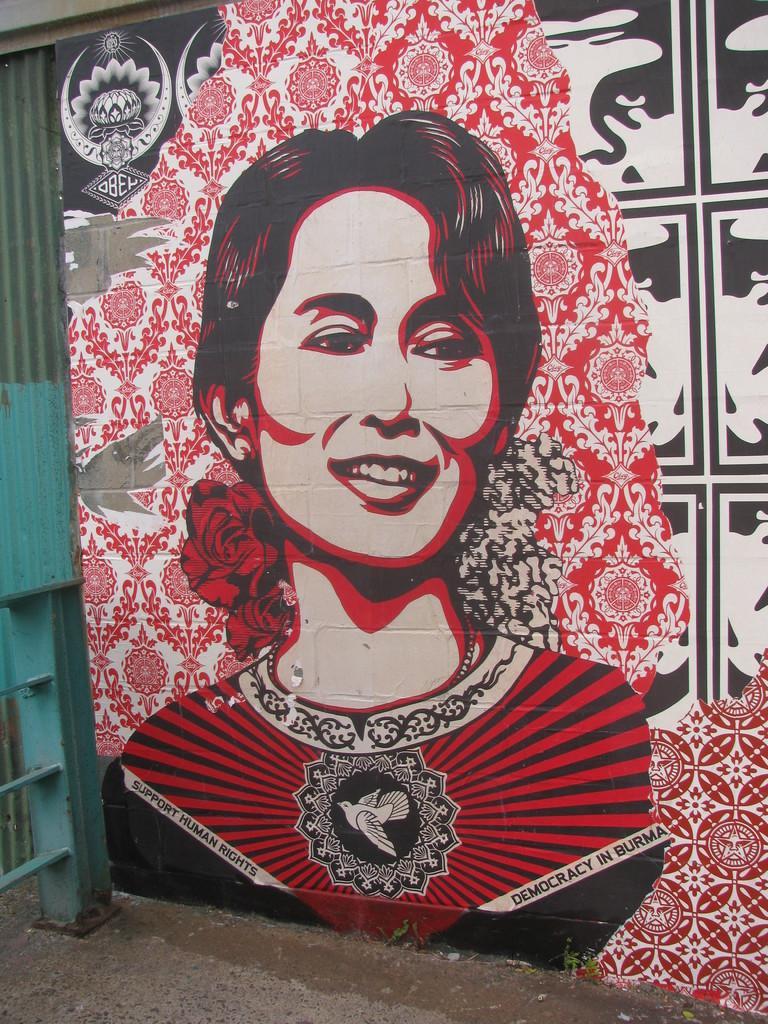Describe this image in one or two sentences. In this image we can see picture of a woman on the board. 